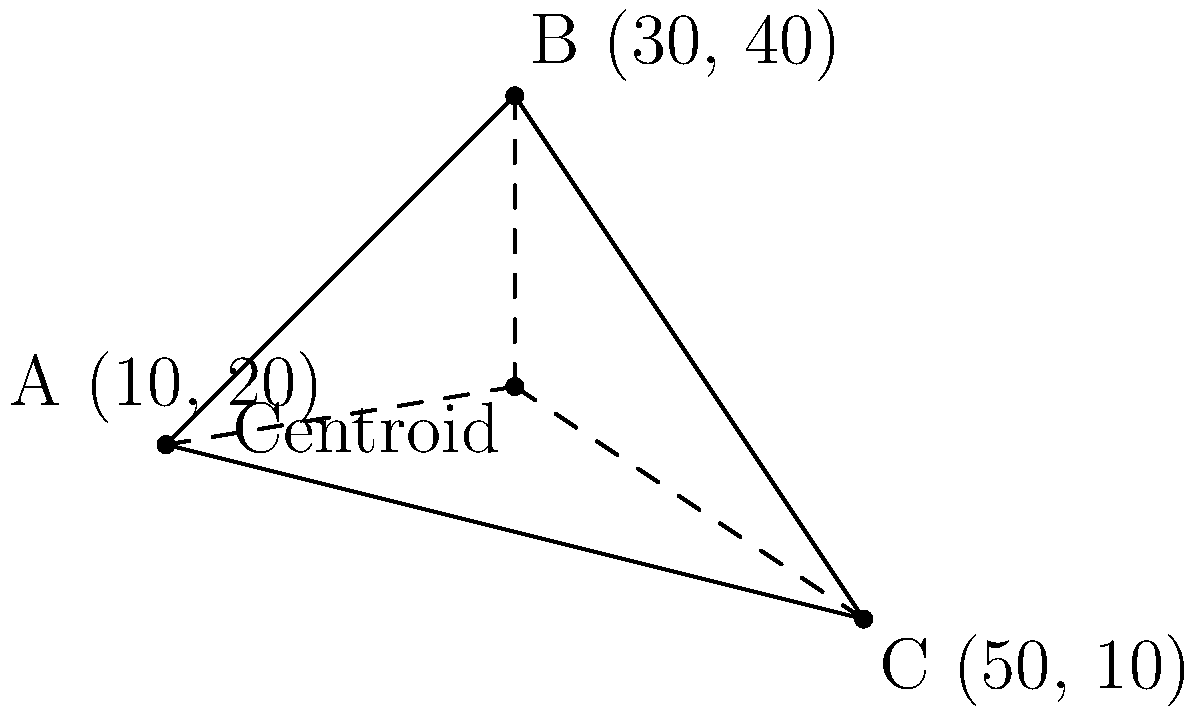In a workplace diversity study, three departments are plotted on a coordinate plane based on their gender diversity (x-axis) and ethnic diversity (y-axis) metrics. Department A is at (10, 20), Department B at (30, 40), and Department C at (50, 10). Calculate the coordinates of the centroid of the triangle formed by these three points, which represents the average diversity metrics across the departments. To find the centroid of a triangle, we need to follow these steps:

1. The centroid divides each median of the triangle in the ratio 2:1, with the longer segment closer to the vertex.

2. The coordinates of the centroid can be calculated by averaging the x-coordinates and y-coordinates of the three vertices separately.

3. For the x-coordinate of the centroid:
   $x_{centroid} = \frac{x_A + x_B + x_C}{3} = \frac{10 + 30 + 50}{3} = \frac{90}{3} = 30$

4. For the y-coordinate of the centroid:
   $y_{centroid} = \frac{y_A + y_B + y_C}{3} = \frac{20 + 40 + 10}{3} = \frac{70}{3} = 23.33$ (rounded to two decimal places)

5. Therefore, the coordinates of the centroid are (30, 23.33).

This point represents the average gender diversity (x-coordinate) and ethnic diversity (y-coordinate) across the three departments.
Answer: (30, 23.33) 